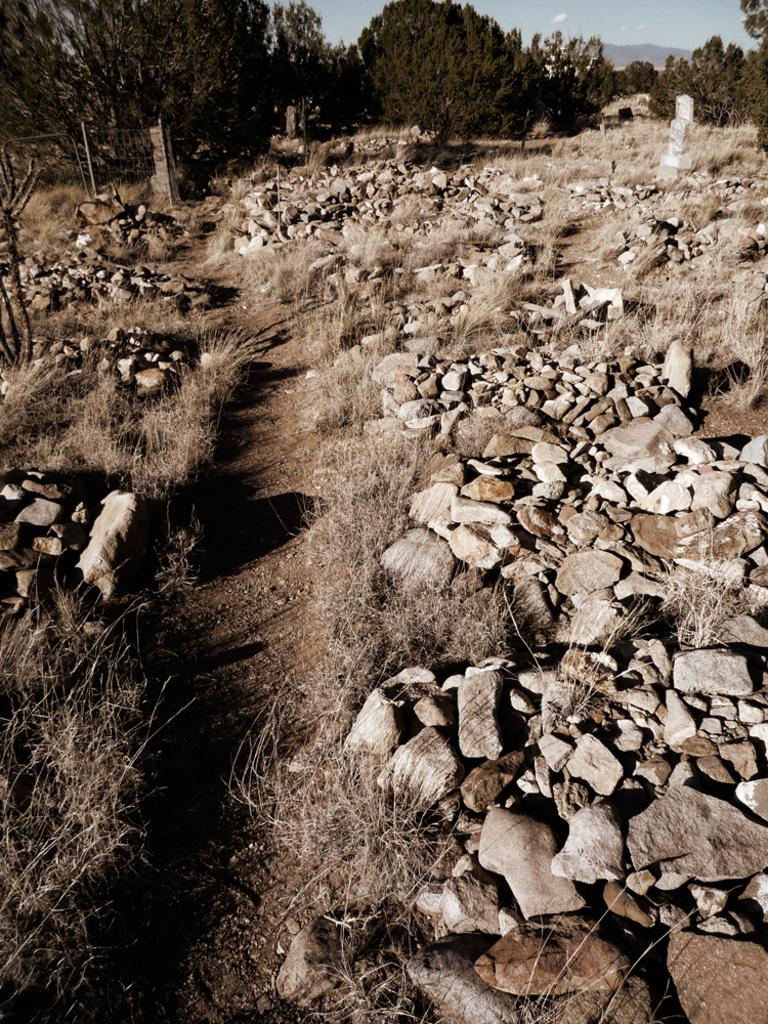What type of natural elements can be seen in the image? There are stones, grass, and trees in the image. What is visible in the background of the image? The sky is visible in the image. What type of structure is present in the image? There is a gate in the image. What type of slope can be seen in the image? There is no slope present in the image. What material is the head made of in the image? There is no head present in the image. 